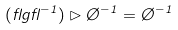<formula> <loc_0><loc_0><loc_500><loc_500>( \gamma g \gamma ^ { - 1 } ) \rhd \chi ^ { - 1 } = \chi ^ { - 1 }</formula> 